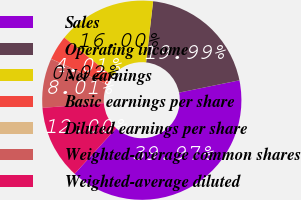<chart> <loc_0><loc_0><loc_500><loc_500><pie_chart><fcel>Sales<fcel>Operating income<fcel>Net earnings<fcel>Basic earnings per share<fcel>Diluted earnings per share<fcel>Weighted-average common shares<fcel>Weighted-average diluted<nl><fcel>39.97%<fcel>19.99%<fcel>16.0%<fcel>4.01%<fcel>0.02%<fcel>8.01%<fcel>12.0%<nl></chart> 